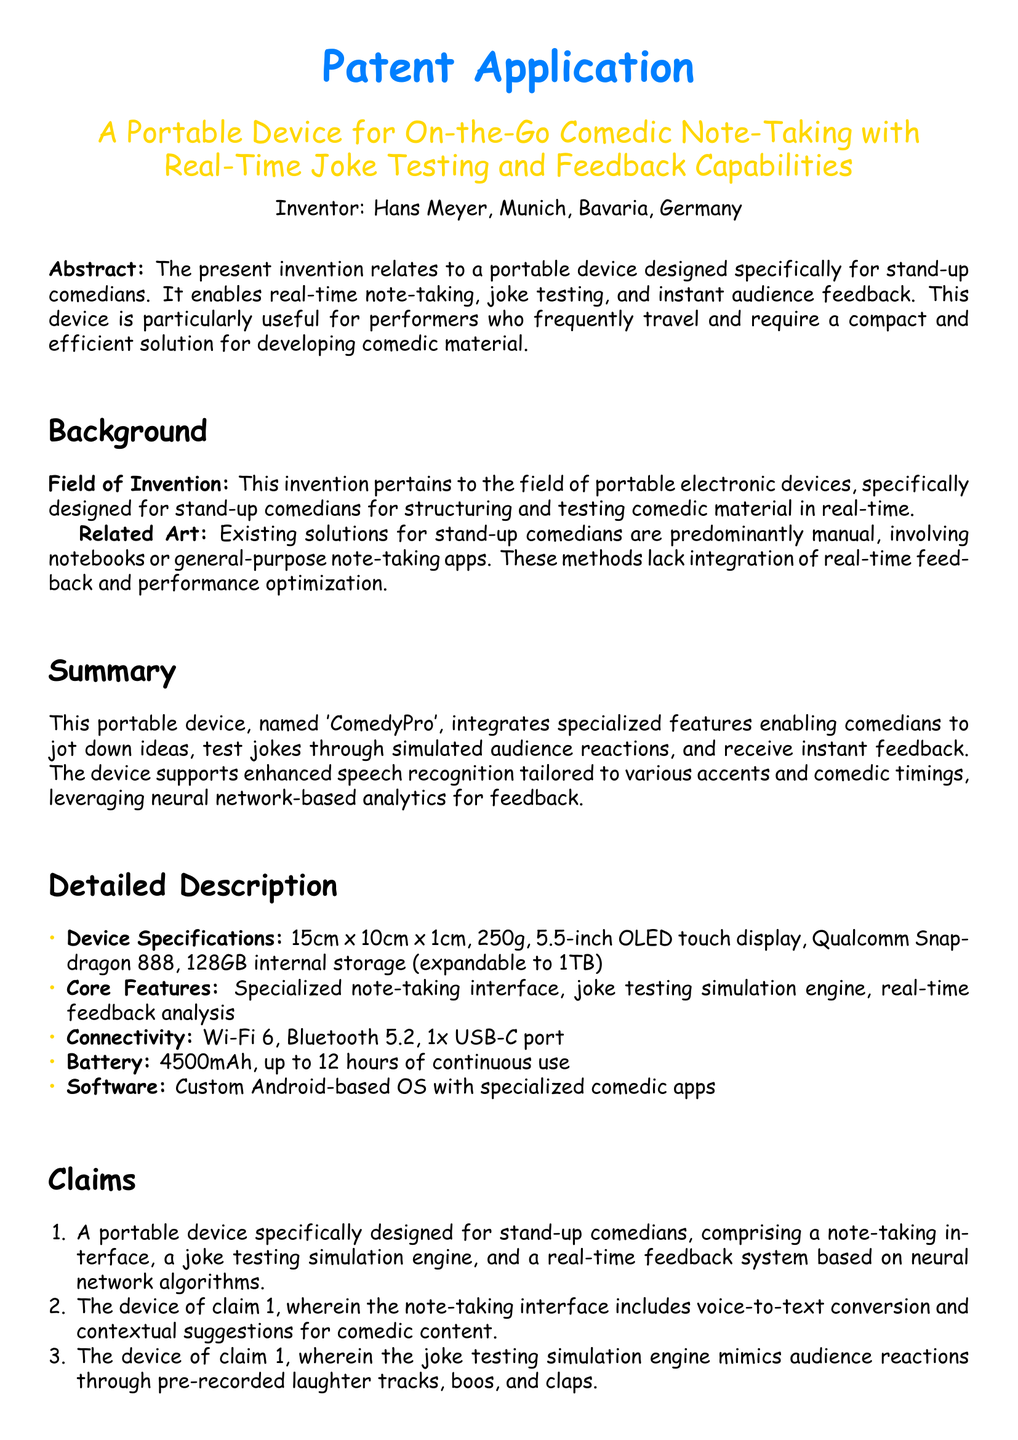What is the title of the invention? The title of the invention is mentioned at the beginning of the document, clearly stating its purpose and unique features.
Answer: A Portable Device for On-the-Go Comedic Note-Taking with Real-Time Joke Testing and Feedback Capabilities Who is the inventor? The inventor's name is highlighted in the document as part of the introduction.
Answer: Hans Meyer What are the dimensions of the device? The document specifies the dimensions in the device specifications section.
Answer: 15cm x 10cm x 1cm What type of display does the device have? The type of display is detailed within the device specifications section of the document.
Answer: 5.5-inch OLED touch display What is the battery capacity? Battery specifications are provided in the detailed description, mentioning its capacity.
Answer: 4500mAh What core feature of the device simulates audience reactions? The document lists core features, including what simulates audience reactions, in the detailed description.
Answer: joke testing simulation engine What is the purpose of the real-time feedback system? The document offers insight into the functionality of the real-time feedback system in a claim.
Answer: statistical analysis and optimization suggestions What connectivity options does the device offer? The document clearly lists the connectivity options in the detailed description, which are essential for modern devices.
Answer: Wi-Fi 6, Bluetooth 5.2, 1x USB-C port What type of operating system does the device use? The software section indicates the type of operating system utilized by the device.
Answer: Custom Android-based OS 